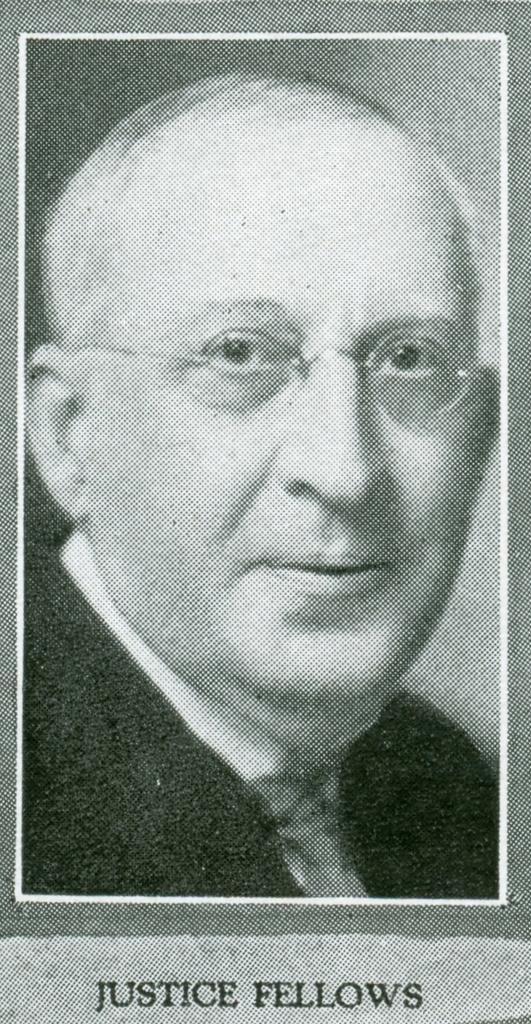Can you describe this image briefly? In this image we can see picture of a man and at the bottom there is a text on the image. 